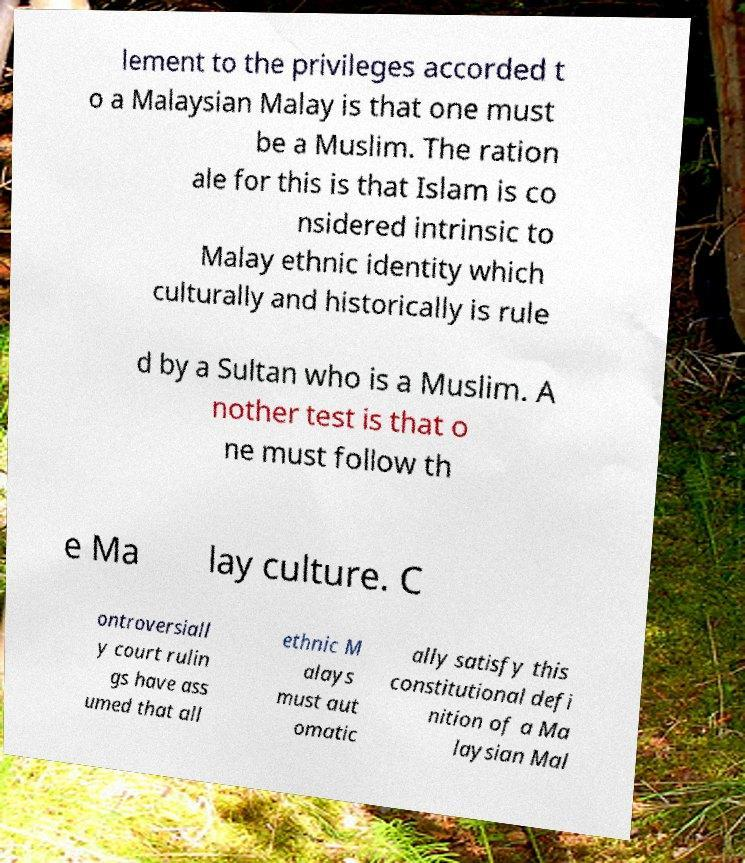Could you assist in decoding the text presented in this image and type it out clearly? lement to the privileges accorded t o a Malaysian Malay is that one must be a Muslim. The ration ale for this is that Islam is co nsidered intrinsic to Malay ethnic identity which culturally and historically is rule d by a Sultan who is a Muslim. A nother test is that o ne must follow th e Ma lay culture. C ontroversiall y court rulin gs have ass umed that all ethnic M alays must aut omatic ally satisfy this constitutional defi nition of a Ma laysian Mal 